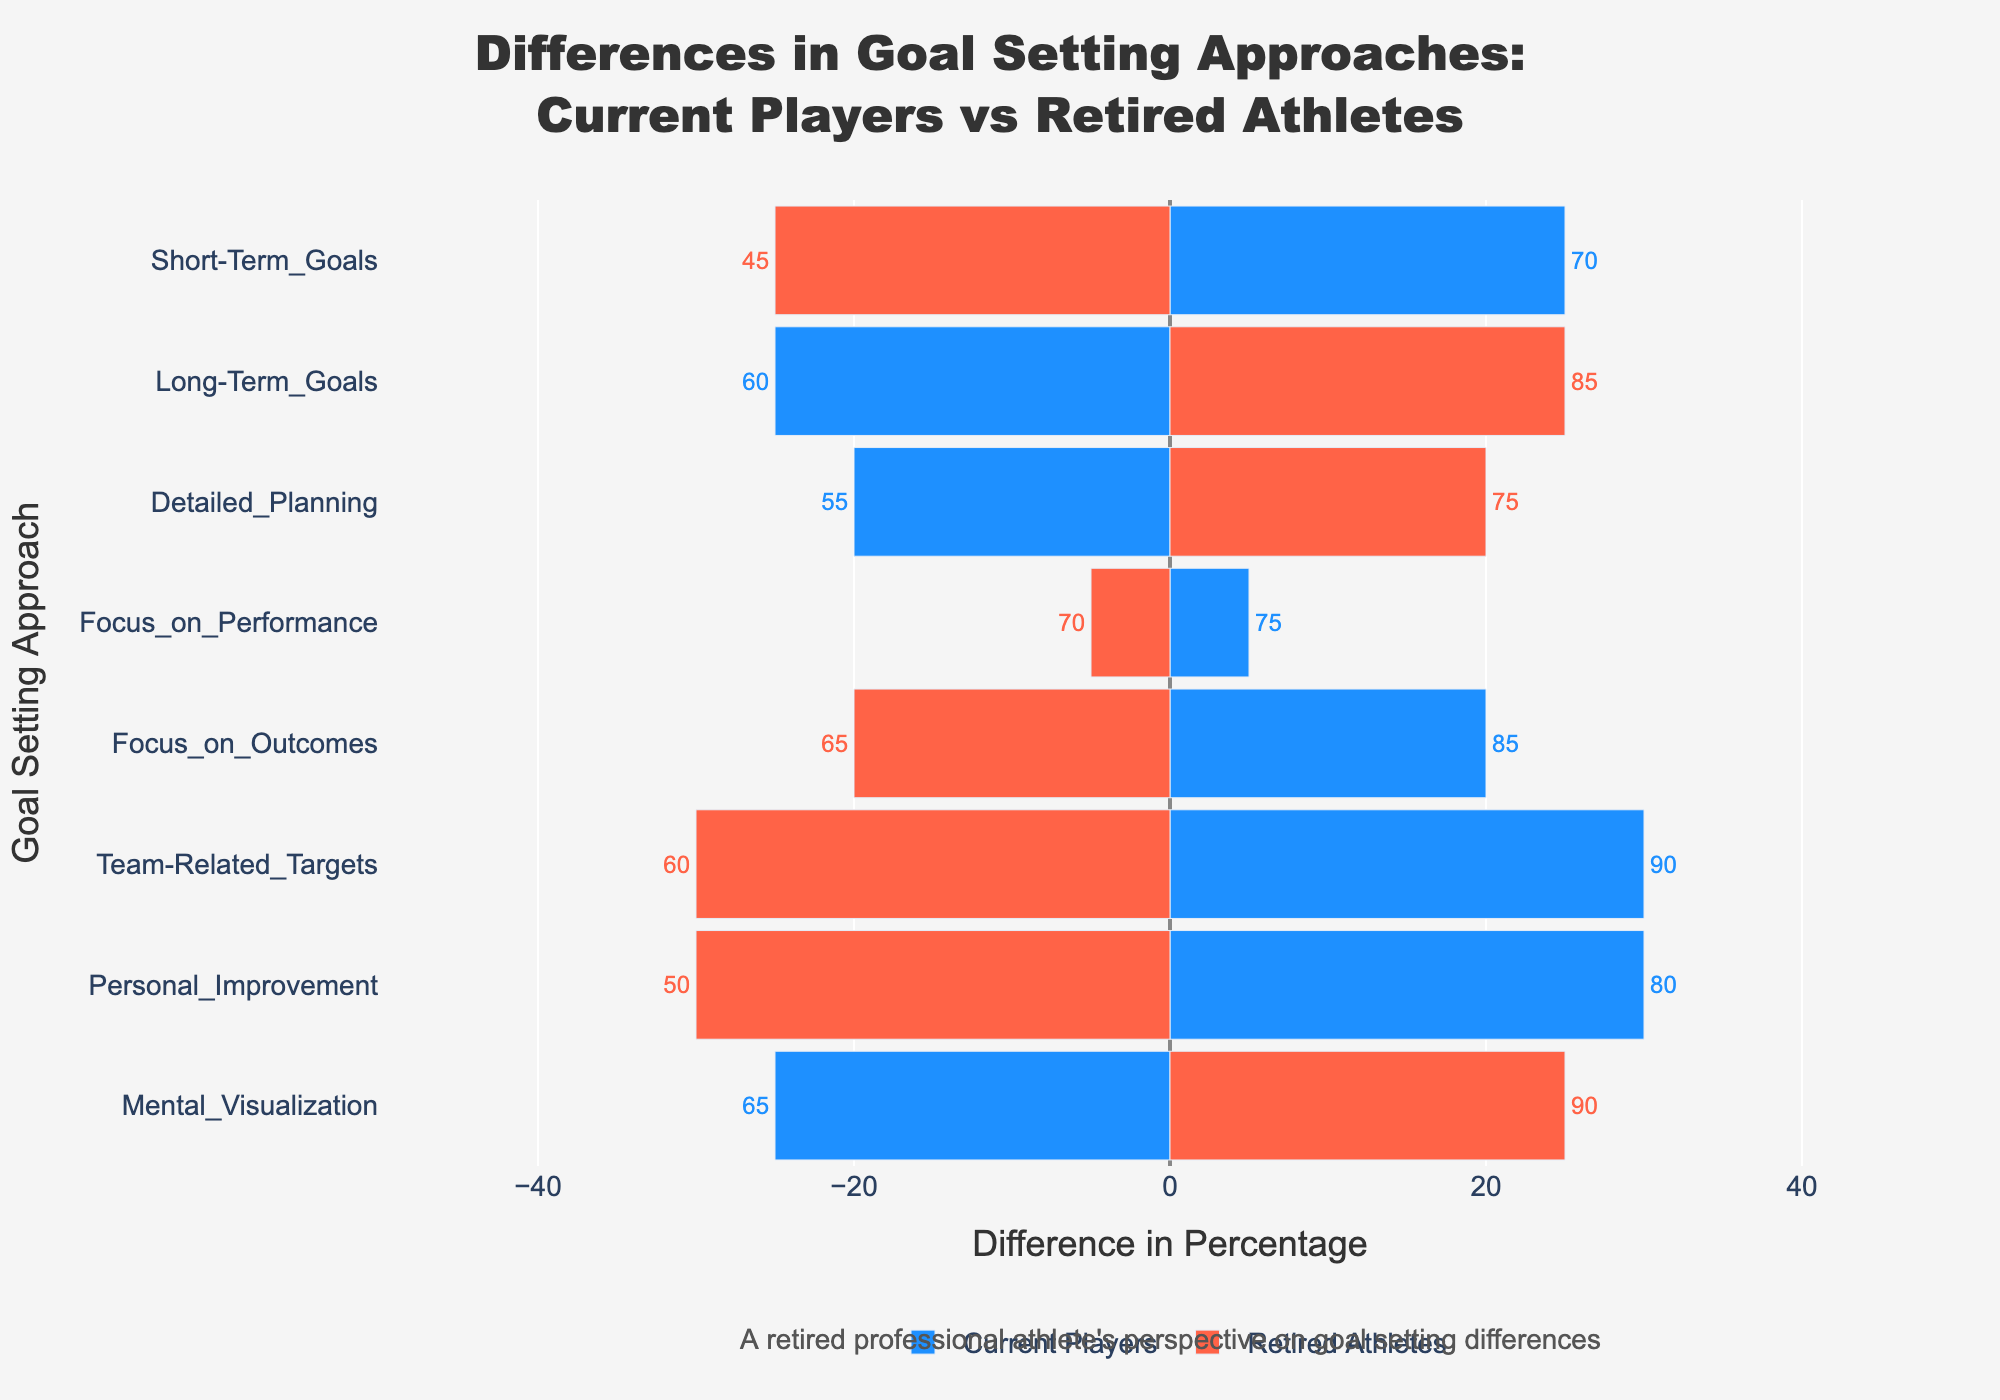What's the difference in preference for Short-Term Goals between Current Players and Retired Athletes? The difference in preference for Short-Term Goals is calculated by subtracting the percentage for Retired Athletes from the percentage for Current Players, which is 70 - 45.
Answer: 25 Which goal-setting approach shows greater preference among Retired Athletes than Current Players? By reviewing the chart, Mental Visualization and Long-Term Goals have taller bars for Retired Athletes than Current Players, indicating higher preference.
Answer: Mental Visualization, Long-Term Goals What is the sum of the percentages for Detailed Planning for both Current Players and Retired Athletes? The percentage for Detailed Planning among Current Players is 55, and for Retired Athletes, it is 75. Adding them together, 55 + 75, gives the sum.
Answer: 130 Between the focus on Performance and Outcomes, which one has a greater difference in preference between Current Players and Retired Athletes? The difference for Focus on Performance is 75 - 70 = 5. For Focus on Outcomes, it is 85 - 65 = 20. By comparing these differences, 20 is greater than 5.
Answer: Focus on Outcomes Which goal-setting approach has the smallest difference in preference between the two groups? By analyzing each bar's length visually, Focus on Performance has the smallest difference between the two groups, which is 5%.
Answer: Focus on Performance How much more do Current Players prefer Team-Related Targets compared to Retired Athletes in percentage points? The preference for Team-Related Targets is 90 for Current Players and 60 for Retired Athletes. The difference, 90 - 60, shows how much more Current Players prefer this approach.
Answer: 30 What is the average percentage difference in preference for Long-Term Goals and Mental Visualization? Calculate the differences: Long-Term Goals (60 - 85 = -25) and Mental Visualization (65 - 90 = -25). Then, find the average: (-25 + -25) / 2 = -25.
Answer: -25 Which goal-setting approach has the highest preference for Current Players? The bar that extends the furthest visually for Current Players represents the highest preference, which is for Team-Related Targets at 90%.
Answer: Team-Related Targets What is the combined percentage difference for Focus on Outcomes and Personal Improvement between the two groups? Calculate the differences: Focus on Outcomes (85 - 65 = 20) and Personal Improvement (80 - 50 = 30). Then, sum these differences: 20 + 30 = 50.
Answer: 50 How much do Retired Athletes prefer Mental Visualization compared to Current Players in percentage points? The percentage for Mental Visualization for Retired Athletes is 90 and for Current Players, it is 65. The difference, 90 - 65, shows the preference of Retired Athletes over Current Players.
Answer: 25 